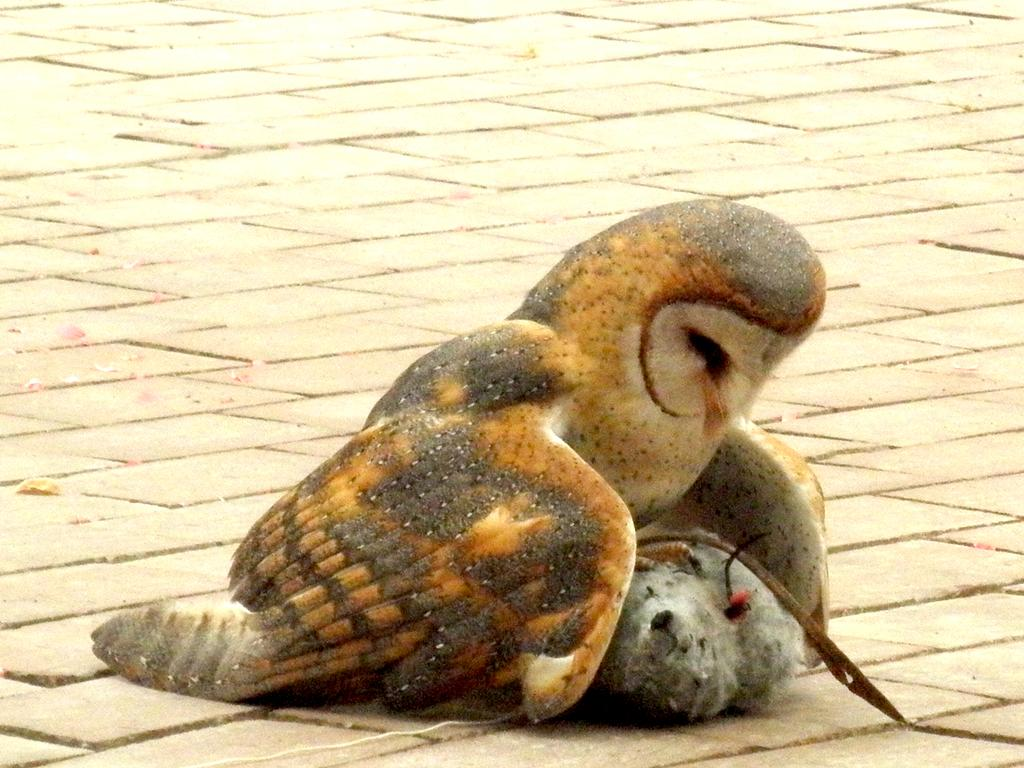What type of animal is in the image? There is an owl in the image. Can you describe the setting where the owl is located? The owl is on a path in the image. What type of apparel is the owl wearing in the image? There is no apparel visible on the owl in the image. How many stars can be seen in the sky above the owl in the image? There is no sky visible in the image, so it is not possible to determine the number of stars. 